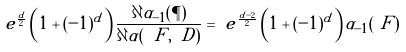Convert formula to latex. <formula><loc_0><loc_0><loc_500><loc_500>\ e ^ { \frac { d } { 2 } } \left ( 1 + ( - 1 ) ^ { d } \right ) \frac { \partial \alpha _ { - 1 } ( \P ) } { \partial \alpha ( \ F , \ D ) } & = \ e ^ { \frac { d - 2 } { 2 } } \left ( 1 + ( - 1 ) ^ { d } \right ) \alpha _ { - 1 } ( \ F )</formula> 